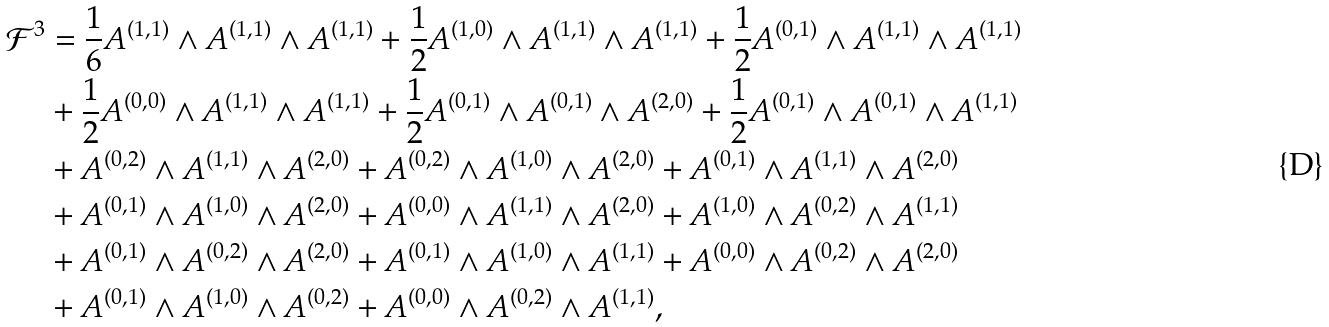<formula> <loc_0><loc_0><loc_500><loc_500>\mathcal { F } ^ { 3 } & = \frac { 1 } { 6 } A ^ { ( 1 , 1 ) } \wedge A ^ { ( 1 , 1 ) } \wedge A ^ { ( 1 , 1 ) } + \frac { 1 } { 2 } A ^ { ( 1 , 0 ) } \wedge A ^ { ( 1 , 1 ) } \wedge A ^ { ( 1 , 1 ) } + \frac { 1 } { 2 } A ^ { ( 0 , 1 ) } \wedge A ^ { ( 1 , 1 ) } \wedge A ^ { ( 1 , 1 ) } \\ & + \frac { 1 } { 2 } A ^ { ( 0 , 0 ) } \wedge A ^ { ( 1 , 1 ) } \wedge A ^ { ( 1 , 1 ) } + \frac { 1 } { 2 } A ^ { ( 0 , 1 ) } \wedge A ^ { ( 0 , 1 ) } \wedge A ^ { ( 2 , 0 ) } + \frac { 1 } { 2 } A ^ { ( 0 , 1 ) } \wedge A ^ { ( 0 , 1 ) } \wedge A ^ { ( 1 , 1 ) } \\ & + A ^ { ( 0 , 2 ) } \wedge A ^ { ( 1 , 1 ) } \wedge A ^ { ( 2 , 0 ) } + A ^ { ( 0 , 2 ) } \wedge A ^ { ( 1 , 0 ) } \wedge A ^ { ( 2 , 0 ) } + A ^ { ( 0 , 1 ) } \wedge A ^ { ( 1 , 1 ) } \wedge A ^ { ( 2 , 0 ) } \\ & + A ^ { ( 0 , 1 ) } \wedge A ^ { ( 1 , 0 ) } \wedge A ^ { ( 2 , 0 ) } + A ^ { ( 0 , 0 ) } \wedge A ^ { ( 1 , 1 ) } \wedge A ^ { ( 2 , 0 ) } + A ^ { ( 1 , 0 ) } \wedge A ^ { ( 0 , 2 ) } \wedge A ^ { ( 1 , 1 ) } \\ & + A ^ { ( 0 , 1 ) } \wedge A ^ { ( 0 , 2 ) } \wedge A ^ { ( 2 , 0 ) } + A ^ { ( 0 , 1 ) } \wedge A ^ { ( 1 , 0 ) } \wedge A ^ { ( 1 , 1 ) } + A ^ { ( 0 , 0 ) } \wedge A ^ { ( 0 , 2 ) } \wedge A ^ { ( 2 , 0 ) } \\ & + A ^ { ( 0 , 1 ) } \wedge A ^ { ( 1 , 0 ) } \wedge A ^ { ( 0 , 2 ) } + A ^ { ( 0 , 0 ) } \wedge A ^ { ( 0 , 2 ) } \wedge A ^ { ( 1 , 1 ) } ,</formula> 